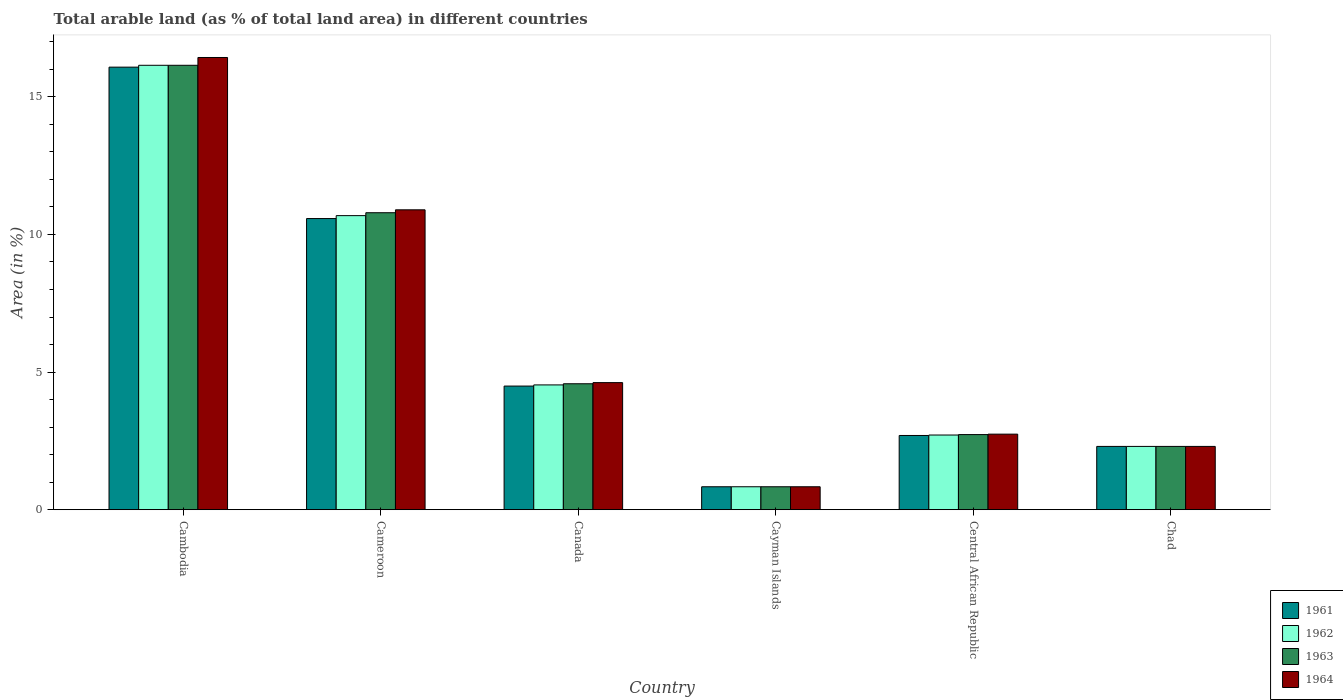How many different coloured bars are there?
Offer a terse response. 4. Are the number of bars per tick equal to the number of legend labels?
Ensure brevity in your answer.  Yes. How many bars are there on the 1st tick from the left?
Offer a very short reply. 4. What is the percentage of arable land in 1964 in Central African Republic?
Keep it short and to the point. 2.74. Across all countries, what is the maximum percentage of arable land in 1961?
Offer a terse response. 16.08. Across all countries, what is the minimum percentage of arable land in 1961?
Give a very brief answer. 0.83. In which country was the percentage of arable land in 1962 maximum?
Give a very brief answer. Cambodia. In which country was the percentage of arable land in 1961 minimum?
Your answer should be compact. Cayman Islands. What is the total percentage of arable land in 1962 in the graph?
Make the answer very short. 37.21. What is the difference between the percentage of arable land in 1963 in Cambodia and that in Central African Republic?
Make the answer very short. 13.42. What is the difference between the percentage of arable land in 1962 in Central African Republic and the percentage of arable land in 1964 in Chad?
Make the answer very short. 0.41. What is the average percentage of arable land in 1961 per country?
Keep it short and to the point. 6.16. What is the difference between the percentage of arable land of/in 1964 and percentage of arable land of/in 1962 in Chad?
Your answer should be compact. 0. What is the ratio of the percentage of arable land in 1961 in Cameroon to that in Chad?
Your answer should be very brief. 4.6. Is the difference between the percentage of arable land in 1964 in Cameroon and Cayman Islands greater than the difference between the percentage of arable land in 1962 in Cameroon and Cayman Islands?
Your answer should be compact. Yes. What is the difference between the highest and the second highest percentage of arable land in 1964?
Offer a very short reply. 5.53. What is the difference between the highest and the lowest percentage of arable land in 1962?
Your answer should be compact. 15.31. In how many countries, is the percentage of arable land in 1964 greater than the average percentage of arable land in 1964 taken over all countries?
Your answer should be compact. 2. Is the sum of the percentage of arable land in 1962 in Cayman Islands and Chad greater than the maximum percentage of arable land in 1963 across all countries?
Keep it short and to the point. No. Is it the case that in every country, the sum of the percentage of arable land in 1961 and percentage of arable land in 1962 is greater than the sum of percentage of arable land in 1964 and percentage of arable land in 1963?
Keep it short and to the point. No. What does the 4th bar from the left in Central African Republic represents?
Provide a short and direct response. 1964. What does the 4th bar from the right in Chad represents?
Your answer should be very brief. 1961. Are all the bars in the graph horizontal?
Ensure brevity in your answer.  No. Does the graph contain grids?
Provide a succinct answer. No. How many legend labels are there?
Keep it short and to the point. 4. How are the legend labels stacked?
Provide a succinct answer. Vertical. What is the title of the graph?
Keep it short and to the point. Total arable land (as % of total land area) in different countries. What is the label or title of the Y-axis?
Provide a succinct answer. Area (in %). What is the Area (in %) of 1961 in Cambodia?
Ensure brevity in your answer.  16.08. What is the Area (in %) of 1962 in Cambodia?
Give a very brief answer. 16.15. What is the Area (in %) in 1963 in Cambodia?
Offer a very short reply. 16.15. What is the Area (in %) in 1964 in Cambodia?
Your answer should be compact. 16.43. What is the Area (in %) of 1961 in Cameroon?
Give a very brief answer. 10.58. What is the Area (in %) of 1962 in Cameroon?
Make the answer very short. 10.68. What is the Area (in %) in 1963 in Cameroon?
Provide a short and direct response. 10.79. What is the Area (in %) of 1964 in Cameroon?
Make the answer very short. 10.89. What is the Area (in %) of 1961 in Canada?
Ensure brevity in your answer.  4.49. What is the Area (in %) of 1962 in Canada?
Give a very brief answer. 4.53. What is the Area (in %) of 1963 in Canada?
Your response must be concise. 4.58. What is the Area (in %) in 1964 in Canada?
Your answer should be very brief. 4.62. What is the Area (in %) in 1961 in Cayman Islands?
Offer a terse response. 0.83. What is the Area (in %) of 1962 in Cayman Islands?
Keep it short and to the point. 0.83. What is the Area (in %) of 1963 in Cayman Islands?
Give a very brief answer. 0.83. What is the Area (in %) of 1964 in Cayman Islands?
Your answer should be compact. 0.83. What is the Area (in %) in 1961 in Central African Republic?
Provide a succinct answer. 2.7. What is the Area (in %) of 1962 in Central African Republic?
Make the answer very short. 2.71. What is the Area (in %) of 1963 in Central African Republic?
Keep it short and to the point. 2.73. What is the Area (in %) in 1964 in Central African Republic?
Ensure brevity in your answer.  2.74. What is the Area (in %) in 1961 in Chad?
Make the answer very short. 2.3. What is the Area (in %) of 1962 in Chad?
Provide a succinct answer. 2.3. What is the Area (in %) in 1963 in Chad?
Keep it short and to the point. 2.3. What is the Area (in %) in 1964 in Chad?
Offer a very short reply. 2.3. Across all countries, what is the maximum Area (in %) in 1961?
Make the answer very short. 16.08. Across all countries, what is the maximum Area (in %) in 1962?
Give a very brief answer. 16.15. Across all countries, what is the maximum Area (in %) of 1963?
Make the answer very short. 16.15. Across all countries, what is the maximum Area (in %) in 1964?
Offer a terse response. 16.43. Across all countries, what is the minimum Area (in %) in 1961?
Provide a short and direct response. 0.83. Across all countries, what is the minimum Area (in %) in 1962?
Keep it short and to the point. 0.83. Across all countries, what is the minimum Area (in %) in 1963?
Give a very brief answer. 0.83. Across all countries, what is the minimum Area (in %) of 1964?
Offer a terse response. 0.83. What is the total Area (in %) in 1961 in the graph?
Provide a short and direct response. 36.98. What is the total Area (in %) of 1962 in the graph?
Offer a very short reply. 37.21. What is the total Area (in %) in 1963 in the graph?
Your response must be concise. 37.37. What is the total Area (in %) of 1964 in the graph?
Offer a terse response. 37.82. What is the difference between the Area (in %) of 1961 in Cambodia and that in Cameroon?
Your answer should be compact. 5.5. What is the difference between the Area (in %) in 1962 in Cambodia and that in Cameroon?
Ensure brevity in your answer.  5.46. What is the difference between the Area (in %) of 1963 in Cambodia and that in Cameroon?
Offer a very short reply. 5.36. What is the difference between the Area (in %) in 1964 in Cambodia and that in Cameroon?
Your answer should be compact. 5.53. What is the difference between the Area (in %) in 1961 in Cambodia and that in Canada?
Offer a terse response. 11.59. What is the difference between the Area (in %) in 1962 in Cambodia and that in Canada?
Your response must be concise. 11.61. What is the difference between the Area (in %) of 1963 in Cambodia and that in Canada?
Make the answer very short. 11.57. What is the difference between the Area (in %) in 1964 in Cambodia and that in Canada?
Provide a short and direct response. 11.81. What is the difference between the Area (in %) in 1961 in Cambodia and that in Cayman Islands?
Your response must be concise. 15.24. What is the difference between the Area (in %) in 1962 in Cambodia and that in Cayman Islands?
Provide a succinct answer. 15.31. What is the difference between the Area (in %) in 1963 in Cambodia and that in Cayman Islands?
Provide a short and direct response. 15.31. What is the difference between the Area (in %) of 1964 in Cambodia and that in Cayman Islands?
Keep it short and to the point. 15.6. What is the difference between the Area (in %) of 1961 in Cambodia and that in Central African Republic?
Provide a succinct answer. 13.38. What is the difference between the Area (in %) of 1962 in Cambodia and that in Central African Republic?
Provide a short and direct response. 13.43. What is the difference between the Area (in %) in 1963 in Cambodia and that in Central African Republic?
Your answer should be very brief. 13.42. What is the difference between the Area (in %) in 1964 in Cambodia and that in Central African Republic?
Your answer should be very brief. 13.68. What is the difference between the Area (in %) of 1961 in Cambodia and that in Chad?
Keep it short and to the point. 13.78. What is the difference between the Area (in %) of 1962 in Cambodia and that in Chad?
Ensure brevity in your answer.  13.85. What is the difference between the Area (in %) in 1963 in Cambodia and that in Chad?
Your response must be concise. 13.85. What is the difference between the Area (in %) in 1964 in Cambodia and that in Chad?
Provide a short and direct response. 14.13. What is the difference between the Area (in %) of 1961 in Cameroon and that in Canada?
Make the answer very short. 6.09. What is the difference between the Area (in %) of 1962 in Cameroon and that in Canada?
Make the answer very short. 6.15. What is the difference between the Area (in %) of 1963 in Cameroon and that in Canada?
Offer a very short reply. 6.21. What is the difference between the Area (in %) of 1964 in Cameroon and that in Canada?
Make the answer very short. 6.28. What is the difference between the Area (in %) of 1961 in Cameroon and that in Cayman Islands?
Your answer should be compact. 9.74. What is the difference between the Area (in %) of 1962 in Cameroon and that in Cayman Islands?
Give a very brief answer. 9.85. What is the difference between the Area (in %) in 1963 in Cameroon and that in Cayman Islands?
Your answer should be very brief. 9.96. What is the difference between the Area (in %) of 1964 in Cameroon and that in Cayman Islands?
Your answer should be very brief. 10.06. What is the difference between the Area (in %) of 1961 in Cameroon and that in Central African Republic?
Keep it short and to the point. 7.88. What is the difference between the Area (in %) of 1962 in Cameroon and that in Central African Republic?
Your response must be concise. 7.97. What is the difference between the Area (in %) in 1963 in Cameroon and that in Central African Republic?
Keep it short and to the point. 8.06. What is the difference between the Area (in %) in 1964 in Cameroon and that in Central African Republic?
Ensure brevity in your answer.  8.15. What is the difference between the Area (in %) of 1961 in Cameroon and that in Chad?
Your answer should be compact. 8.28. What is the difference between the Area (in %) in 1962 in Cameroon and that in Chad?
Your answer should be compact. 8.38. What is the difference between the Area (in %) of 1963 in Cameroon and that in Chad?
Give a very brief answer. 8.49. What is the difference between the Area (in %) in 1964 in Cameroon and that in Chad?
Your answer should be compact. 8.6. What is the difference between the Area (in %) of 1961 in Canada and that in Cayman Islands?
Offer a very short reply. 3.66. What is the difference between the Area (in %) in 1962 in Canada and that in Cayman Islands?
Make the answer very short. 3.7. What is the difference between the Area (in %) in 1963 in Canada and that in Cayman Islands?
Provide a short and direct response. 3.74. What is the difference between the Area (in %) of 1964 in Canada and that in Cayman Islands?
Your answer should be compact. 3.78. What is the difference between the Area (in %) in 1961 in Canada and that in Central African Republic?
Provide a succinct answer. 1.79. What is the difference between the Area (in %) in 1962 in Canada and that in Central African Republic?
Offer a very short reply. 1.82. What is the difference between the Area (in %) of 1963 in Canada and that in Central African Republic?
Your answer should be compact. 1.85. What is the difference between the Area (in %) of 1964 in Canada and that in Central African Republic?
Provide a succinct answer. 1.87. What is the difference between the Area (in %) in 1961 in Canada and that in Chad?
Provide a succinct answer. 2.19. What is the difference between the Area (in %) in 1962 in Canada and that in Chad?
Make the answer very short. 2.23. What is the difference between the Area (in %) in 1963 in Canada and that in Chad?
Offer a very short reply. 2.28. What is the difference between the Area (in %) of 1964 in Canada and that in Chad?
Your answer should be very brief. 2.32. What is the difference between the Area (in %) in 1961 in Cayman Islands and that in Central African Republic?
Your response must be concise. -1.86. What is the difference between the Area (in %) in 1962 in Cayman Islands and that in Central African Republic?
Provide a succinct answer. -1.88. What is the difference between the Area (in %) in 1963 in Cayman Islands and that in Central African Republic?
Offer a terse response. -1.9. What is the difference between the Area (in %) in 1964 in Cayman Islands and that in Central African Republic?
Keep it short and to the point. -1.91. What is the difference between the Area (in %) in 1961 in Cayman Islands and that in Chad?
Offer a terse response. -1.47. What is the difference between the Area (in %) in 1962 in Cayman Islands and that in Chad?
Ensure brevity in your answer.  -1.47. What is the difference between the Area (in %) of 1963 in Cayman Islands and that in Chad?
Your answer should be very brief. -1.47. What is the difference between the Area (in %) of 1964 in Cayman Islands and that in Chad?
Make the answer very short. -1.47. What is the difference between the Area (in %) in 1961 in Central African Republic and that in Chad?
Make the answer very short. 0.4. What is the difference between the Area (in %) of 1962 in Central African Republic and that in Chad?
Provide a succinct answer. 0.41. What is the difference between the Area (in %) of 1963 in Central African Republic and that in Chad?
Offer a very short reply. 0.43. What is the difference between the Area (in %) in 1964 in Central African Republic and that in Chad?
Offer a terse response. 0.45. What is the difference between the Area (in %) in 1961 in Cambodia and the Area (in %) in 1962 in Cameroon?
Your response must be concise. 5.39. What is the difference between the Area (in %) in 1961 in Cambodia and the Area (in %) in 1963 in Cameroon?
Offer a terse response. 5.29. What is the difference between the Area (in %) of 1961 in Cambodia and the Area (in %) of 1964 in Cameroon?
Give a very brief answer. 5.18. What is the difference between the Area (in %) in 1962 in Cambodia and the Area (in %) in 1963 in Cameroon?
Offer a very short reply. 5.36. What is the difference between the Area (in %) in 1962 in Cambodia and the Area (in %) in 1964 in Cameroon?
Provide a succinct answer. 5.25. What is the difference between the Area (in %) of 1963 in Cambodia and the Area (in %) of 1964 in Cameroon?
Your answer should be compact. 5.25. What is the difference between the Area (in %) in 1961 in Cambodia and the Area (in %) in 1962 in Canada?
Make the answer very short. 11.54. What is the difference between the Area (in %) in 1961 in Cambodia and the Area (in %) in 1963 in Canada?
Provide a short and direct response. 11.5. What is the difference between the Area (in %) of 1961 in Cambodia and the Area (in %) of 1964 in Canada?
Your answer should be very brief. 11.46. What is the difference between the Area (in %) of 1962 in Cambodia and the Area (in %) of 1963 in Canada?
Your answer should be compact. 11.57. What is the difference between the Area (in %) of 1962 in Cambodia and the Area (in %) of 1964 in Canada?
Make the answer very short. 11.53. What is the difference between the Area (in %) of 1963 in Cambodia and the Area (in %) of 1964 in Canada?
Make the answer very short. 11.53. What is the difference between the Area (in %) of 1961 in Cambodia and the Area (in %) of 1962 in Cayman Islands?
Provide a succinct answer. 15.24. What is the difference between the Area (in %) in 1961 in Cambodia and the Area (in %) in 1963 in Cayman Islands?
Make the answer very short. 15.24. What is the difference between the Area (in %) in 1961 in Cambodia and the Area (in %) in 1964 in Cayman Islands?
Provide a succinct answer. 15.24. What is the difference between the Area (in %) of 1962 in Cambodia and the Area (in %) of 1963 in Cayman Islands?
Give a very brief answer. 15.31. What is the difference between the Area (in %) in 1962 in Cambodia and the Area (in %) in 1964 in Cayman Islands?
Your answer should be very brief. 15.31. What is the difference between the Area (in %) in 1963 in Cambodia and the Area (in %) in 1964 in Cayman Islands?
Offer a terse response. 15.31. What is the difference between the Area (in %) in 1961 in Cambodia and the Area (in %) in 1962 in Central African Republic?
Ensure brevity in your answer.  13.36. What is the difference between the Area (in %) in 1961 in Cambodia and the Area (in %) in 1963 in Central African Republic?
Ensure brevity in your answer.  13.35. What is the difference between the Area (in %) in 1961 in Cambodia and the Area (in %) in 1964 in Central African Republic?
Make the answer very short. 13.33. What is the difference between the Area (in %) in 1962 in Cambodia and the Area (in %) in 1963 in Central African Republic?
Your answer should be compact. 13.42. What is the difference between the Area (in %) in 1962 in Cambodia and the Area (in %) in 1964 in Central African Republic?
Provide a succinct answer. 13.4. What is the difference between the Area (in %) of 1963 in Cambodia and the Area (in %) of 1964 in Central African Republic?
Your answer should be compact. 13.4. What is the difference between the Area (in %) of 1961 in Cambodia and the Area (in %) of 1962 in Chad?
Offer a very short reply. 13.78. What is the difference between the Area (in %) of 1961 in Cambodia and the Area (in %) of 1963 in Chad?
Offer a very short reply. 13.78. What is the difference between the Area (in %) in 1961 in Cambodia and the Area (in %) in 1964 in Chad?
Provide a short and direct response. 13.78. What is the difference between the Area (in %) in 1962 in Cambodia and the Area (in %) in 1963 in Chad?
Make the answer very short. 13.85. What is the difference between the Area (in %) of 1962 in Cambodia and the Area (in %) of 1964 in Chad?
Give a very brief answer. 13.85. What is the difference between the Area (in %) of 1963 in Cambodia and the Area (in %) of 1964 in Chad?
Your answer should be compact. 13.85. What is the difference between the Area (in %) of 1961 in Cameroon and the Area (in %) of 1962 in Canada?
Make the answer very short. 6.04. What is the difference between the Area (in %) in 1961 in Cameroon and the Area (in %) in 1963 in Canada?
Offer a terse response. 6. What is the difference between the Area (in %) of 1961 in Cameroon and the Area (in %) of 1964 in Canada?
Keep it short and to the point. 5.96. What is the difference between the Area (in %) of 1962 in Cameroon and the Area (in %) of 1963 in Canada?
Provide a short and direct response. 6.11. What is the difference between the Area (in %) in 1962 in Cameroon and the Area (in %) in 1964 in Canada?
Provide a short and direct response. 6.07. What is the difference between the Area (in %) in 1963 in Cameroon and the Area (in %) in 1964 in Canada?
Your answer should be very brief. 6.17. What is the difference between the Area (in %) in 1961 in Cameroon and the Area (in %) in 1962 in Cayman Islands?
Give a very brief answer. 9.74. What is the difference between the Area (in %) in 1961 in Cameroon and the Area (in %) in 1963 in Cayman Islands?
Your answer should be compact. 9.74. What is the difference between the Area (in %) of 1961 in Cameroon and the Area (in %) of 1964 in Cayman Islands?
Keep it short and to the point. 9.74. What is the difference between the Area (in %) of 1962 in Cameroon and the Area (in %) of 1963 in Cayman Islands?
Ensure brevity in your answer.  9.85. What is the difference between the Area (in %) of 1962 in Cameroon and the Area (in %) of 1964 in Cayman Islands?
Your answer should be very brief. 9.85. What is the difference between the Area (in %) of 1963 in Cameroon and the Area (in %) of 1964 in Cayman Islands?
Your response must be concise. 9.96. What is the difference between the Area (in %) of 1961 in Cameroon and the Area (in %) of 1962 in Central African Republic?
Your answer should be compact. 7.86. What is the difference between the Area (in %) of 1961 in Cameroon and the Area (in %) of 1963 in Central African Republic?
Provide a succinct answer. 7.85. What is the difference between the Area (in %) in 1961 in Cameroon and the Area (in %) in 1964 in Central African Republic?
Offer a very short reply. 7.83. What is the difference between the Area (in %) in 1962 in Cameroon and the Area (in %) in 1963 in Central African Republic?
Give a very brief answer. 7.95. What is the difference between the Area (in %) of 1962 in Cameroon and the Area (in %) of 1964 in Central African Republic?
Your answer should be very brief. 7.94. What is the difference between the Area (in %) in 1963 in Cameroon and the Area (in %) in 1964 in Central African Republic?
Offer a terse response. 8.04. What is the difference between the Area (in %) in 1961 in Cameroon and the Area (in %) in 1962 in Chad?
Make the answer very short. 8.28. What is the difference between the Area (in %) of 1961 in Cameroon and the Area (in %) of 1963 in Chad?
Keep it short and to the point. 8.28. What is the difference between the Area (in %) of 1961 in Cameroon and the Area (in %) of 1964 in Chad?
Your answer should be very brief. 8.28. What is the difference between the Area (in %) of 1962 in Cameroon and the Area (in %) of 1963 in Chad?
Give a very brief answer. 8.38. What is the difference between the Area (in %) in 1962 in Cameroon and the Area (in %) in 1964 in Chad?
Ensure brevity in your answer.  8.38. What is the difference between the Area (in %) of 1963 in Cameroon and the Area (in %) of 1964 in Chad?
Your answer should be very brief. 8.49. What is the difference between the Area (in %) in 1961 in Canada and the Area (in %) in 1962 in Cayman Islands?
Offer a very short reply. 3.66. What is the difference between the Area (in %) of 1961 in Canada and the Area (in %) of 1963 in Cayman Islands?
Give a very brief answer. 3.66. What is the difference between the Area (in %) in 1961 in Canada and the Area (in %) in 1964 in Cayman Islands?
Your answer should be very brief. 3.66. What is the difference between the Area (in %) in 1962 in Canada and the Area (in %) in 1964 in Cayman Islands?
Make the answer very short. 3.7. What is the difference between the Area (in %) of 1963 in Canada and the Area (in %) of 1964 in Cayman Islands?
Provide a succinct answer. 3.74. What is the difference between the Area (in %) of 1961 in Canada and the Area (in %) of 1962 in Central African Republic?
Ensure brevity in your answer.  1.78. What is the difference between the Area (in %) in 1961 in Canada and the Area (in %) in 1963 in Central African Republic?
Provide a short and direct response. 1.76. What is the difference between the Area (in %) of 1961 in Canada and the Area (in %) of 1964 in Central African Republic?
Give a very brief answer. 1.75. What is the difference between the Area (in %) in 1962 in Canada and the Area (in %) in 1963 in Central African Republic?
Provide a succinct answer. 1.8. What is the difference between the Area (in %) of 1962 in Canada and the Area (in %) of 1964 in Central African Republic?
Ensure brevity in your answer.  1.79. What is the difference between the Area (in %) in 1963 in Canada and the Area (in %) in 1964 in Central African Republic?
Offer a terse response. 1.83. What is the difference between the Area (in %) of 1961 in Canada and the Area (in %) of 1962 in Chad?
Your response must be concise. 2.19. What is the difference between the Area (in %) in 1961 in Canada and the Area (in %) in 1963 in Chad?
Your answer should be very brief. 2.19. What is the difference between the Area (in %) of 1961 in Canada and the Area (in %) of 1964 in Chad?
Your response must be concise. 2.19. What is the difference between the Area (in %) in 1962 in Canada and the Area (in %) in 1963 in Chad?
Make the answer very short. 2.23. What is the difference between the Area (in %) in 1962 in Canada and the Area (in %) in 1964 in Chad?
Provide a succinct answer. 2.23. What is the difference between the Area (in %) of 1963 in Canada and the Area (in %) of 1964 in Chad?
Give a very brief answer. 2.28. What is the difference between the Area (in %) of 1961 in Cayman Islands and the Area (in %) of 1962 in Central African Republic?
Your response must be concise. -1.88. What is the difference between the Area (in %) of 1961 in Cayman Islands and the Area (in %) of 1963 in Central African Republic?
Your answer should be compact. -1.9. What is the difference between the Area (in %) in 1961 in Cayman Islands and the Area (in %) in 1964 in Central African Republic?
Your response must be concise. -1.91. What is the difference between the Area (in %) of 1962 in Cayman Islands and the Area (in %) of 1963 in Central African Republic?
Your response must be concise. -1.9. What is the difference between the Area (in %) in 1962 in Cayman Islands and the Area (in %) in 1964 in Central African Republic?
Your answer should be very brief. -1.91. What is the difference between the Area (in %) of 1963 in Cayman Islands and the Area (in %) of 1964 in Central African Republic?
Your response must be concise. -1.91. What is the difference between the Area (in %) of 1961 in Cayman Islands and the Area (in %) of 1962 in Chad?
Provide a short and direct response. -1.47. What is the difference between the Area (in %) in 1961 in Cayman Islands and the Area (in %) in 1963 in Chad?
Your answer should be compact. -1.47. What is the difference between the Area (in %) of 1961 in Cayman Islands and the Area (in %) of 1964 in Chad?
Your response must be concise. -1.47. What is the difference between the Area (in %) of 1962 in Cayman Islands and the Area (in %) of 1963 in Chad?
Your answer should be very brief. -1.47. What is the difference between the Area (in %) of 1962 in Cayman Islands and the Area (in %) of 1964 in Chad?
Ensure brevity in your answer.  -1.47. What is the difference between the Area (in %) in 1963 in Cayman Islands and the Area (in %) in 1964 in Chad?
Provide a short and direct response. -1.47. What is the difference between the Area (in %) in 1961 in Central African Republic and the Area (in %) in 1962 in Chad?
Offer a very short reply. 0.4. What is the difference between the Area (in %) of 1961 in Central African Republic and the Area (in %) of 1963 in Chad?
Ensure brevity in your answer.  0.4. What is the difference between the Area (in %) of 1961 in Central African Republic and the Area (in %) of 1964 in Chad?
Provide a short and direct response. 0.4. What is the difference between the Area (in %) of 1962 in Central African Republic and the Area (in %) of 1963 in Chad?
Your answer should be compact. 0.41. What is the difference between the Area (in %) in 1962 in Central African Republic and the Area (in %) in 1964 in Chad?
Your answer should be compact. 0.41. What is the difference between the Area (in %) in 1963 in Central African Republic and the Area (in %) in 1964 in Chad?
Provide a succinct answer. 0.43. What is the average Area (in %) in 1961 per country?
Your answer should be compact. 6.16. What is the average Area (in %) of 1962 per country?
Your response must be concise. 6.2. What is the average Area (in %) in 1963 per country?
Keep it short and to the point. 6.23. What is the average Area (in %) in 1964 per country?
Provide a short and direct response. 6.3. What is the difference between the Area (in %) in 1961 and Area (in %) in 1962 in Cambodia?
Your response must be concise. -0.07. What is the difference between the Area (in %) in 1961 and Area (in %) in 1963 in Cambodia?
Keep it short and to the point. -0.07. What is the difference between the Area (in %) in 1961 and Area (in %) in 1964 in Cambodia?
Keep it short and to the point. -0.35. What is the difference between the Area (in %) of 1962 and Area (in %) of 1963 in Cambodia?
Your answer should be very brief. 0. What is the difference between the Area (in %) of 1962 and Area (in %) of 1964 in Cambodia?
Your answer should be compact. -0.28. What is the difference between the Area (in %) in 1963 and Area (in %) in 1964 in Cambodia?
Ensure brevity in your answer.  -0.28. What is the difference between the Area (in %) in 1961 and Area (in %) in 1962 in Cameroon?
Ensure brevity in your answer.  -0.11. What is the difference between the Area (in %) in 1961 and Area (in %) in 1963 in Cameroon?
Your response must be concise. -0.21. What is the difference between the Area (in %) of 1961 and Area (in %) of 1964 in Cameroon?
Provide a short and direct response. -0.32. What is the difference between the Area (in %) of 1962 and Area (in %) of 1963 in Cameroon?
Make the answer very short. -0.11. What is the difference between the Area (in %) of 1962 and Area (in %) of 1964 in Cameroon?
Keep it short and to the point. -0.21. What is the difference between the Area (in %) in 1963 and Area (in %) in 1964 in Cameroon?
Make the answer very short. -0.11. What is the difference between the Area (in %) of 1961 and Area (in %) of 1962 in Canada?
Offer a very short reply. -0.04. What is the difference between the Area (in %) of 1961 and Area (in %) of 1963 in Canada?
Your answer should be very brief. -0.08. What is the difference between the Area (in %) in 1961 and Area (in %) in 1964 in Canada?
Provide a succinct answer. -0.13. What is the difference between the Area (in %) in 1962 and Area (in %) in 1963 in Canada?
Your answer should be compact. -0.04. What is the difference between the Area (in %) of 1962 and Area (in %) of 1964 in Canada?
Make the answer very short. -0.08. What is the difference between the Area (in %) of 1963 and Area (in %) of 1964 in Canada?
Offer a very short reply. -0.04. What is the difference between the Area (in %) in 1961 and Area (in %) in 1963 in Cayman Islands?
Keep it short and to the point. 0. What is the difference between the Area (in %) of 1962 and Area (in %) of 1963 in Cayman Islands?
Offer a terse response. 0. What is the difference between the Area (in %) in 1961 and Area (in %) in 1962 in Central African Republic?
Keep it short and to the point. -0.02. What is the difference between the Area (in %) of 1961 and Area (in %) of 1963 in Central African Republic?
Make the answer very short. -0.03. What is the difference between the Area (in %) of 1961 and Area (in %) of 1964 in Central African Republic?
Your answer should be compact. -0.05. What is the difference between the Area (in %) in 1962 and Area (in %) in 1963 in Central African Republic?
Keep it short and to the point. -0.02. What is the difference between the Area (in %) of 1962 and Area (in %) of 1964 in Central African Republic?
Provide a short and direct response. -0.03. What is the difference between the Area (in %) in 1963 and Area (in %) in 1964 in Central African Republic?
Keep it short and to the point. -0.02. What is the difference between the Area (in %) in 1961 and Area (in %) in 1964 in Chad?
Your response must be concise. 0. What is the difference between the Area (in %) in 1963 and Area (in %) in 1964 in Chad?
Ensure brevity in your answer.  0. What is the ratio of the Area (in %) of 1961 in Cambodia to that in Cameroon?
Your answer should be very brief. 1.52. What is the ratio of the Area (in %) of 1962 in Cambodia to that in Cameroon?
Keep it short and to the point. 1.51. What is the ratio of the Area (in %) of 1963 in Cambodia to that in Cameroon?
Offer a terse response. 1.5. What is the ratio of the Area (in %) of 1964 in Cambodia to that in Cameroon?
Provide a succinct answer. 1.51. What is the ratio of the Area (in %) in 1961 in Cambodia to that in Canada?
Your answer should be very brief. 3.58. What is the ratio of the Area (in %) in 1962 in Cambodia to that in Canada?
Ensure brevity in your answer.  3.56. What is the ratio of the Area (in %) of 1963 in Cambodia to that in Canada?
Your response must be concise. 3.53. What is the ratio of the Area (in %) in 1964 in Cambodia to that in Canada?
Your answer should be very brief. 3.56. What is the ratio of the Area (in %) of 1961 in Cambodia to that in Cayman Islands?
Provide a short and direct response. 19.29. What is the ratio of the Area (in %) in 1962 in Cambodia to that in Cayman Islands?
Offer a terse response. 19.37. What is the ratio of the Area (in %) of 1963 in Cambodia to that in Cayman Islands?
Ensure brevity in your answer.  19.37. What is the ratio of the Area (in %) in 1964 in Cambodia to that in Cayman Islands?
Offer a very short reply. 19.71. What is the ratio of the Area (in %) in 1961 in Cambodia to that in Central African Republic?
Offer a very short reply. 5.96. What is the ratio of the Area (in %) in 1962 in Cambodia to that in Central African Republic?
Make the answer very short. 5.95. What is the ratio of the Area (in %) in 1963 in Cambodia to that in Central African Republic?
Your answer should be very brief. 5.92. What is the ratio of the Area (in %) of 1964 in Cambodia to that in Central African Republic?
Provide a succinct answer. 5.99. What is the ratio of the Area (in %) in 1961 in Cambodia to that in Chad?
Your response must be concise. 6.99. What is the ratio of the Area (in %) in 1962 in Cambodia to that in Chad?
Offer a terse response. 7.02. What is the ratio of the Area (in %) in 1963 in Cambodia to that in Chad?
Provide a short and direct response. 7.02. What is the ratio of the Area (in %) in 1964 in Cambodia to that in Chad?
Offer a very short reply. 7.15. What is the ratio of the Area (in %) in 1961 in Cameroon to that in Canada?
Offer a very short reply. 2.35. What is the ratio of the Area (in %) in 1962 in Cameroon to that in Canada?
Your response must be concise. 2.36. What is the ratio of the Area (in %) of 1963 in Cameroon to that in Canada?
Give a very brief answer. 2.36. What is the ratio of the Area (in %) of 1964 in Cameroon to that in Canada?
Offer a very short reply. 2.36. What is the ratio of the Area (in %) in 1961 in Cameroon to that in Cayman Islands?
Your answer should be very brief. 12.69. What is the ratio of the Area (in %) in 1962 in Cameroon to that in Cayman Islands?
Offer a terse response. 12.82. What is the ratio of the Area (in %) of 1963 in Cameroon to that in Cayman Islands?
Give a very brief answer. 12.95. What is the ratio of the Area (in %) of 1964 in Cameroon to that in Cayman Islands?
Ensure brevity in your answer.  13.07. What is the ratio of the Area (in %) of 1961 in Cameroon to that in Central African Republic?
Your answer should be compact. 3.92. What is the ratio of the Area (in %) of 1962 in Cameroon to that in Central African Republic?
Make the answer very short. 3.94. What is the ratio of the Area (in %) in 1963 in Cameroon to that in Central African Republic?
Ensure brevity in your answer.  3.95. What is the ratio of the Area (in %) in 1964 in Cameroon to that in Central African Republic?
Keep it short and to the point. 3.97. What is the ratio of the Area (in %) of 1961 in Cameroon to that in Chad?
Provide a short and direct response. 4.6. What is the ratio of the Area (in %) of 1962 in Cameroon to that in Chad?
Offer a very short reply. 4.65. What is the ratio of the Area (in %) in 1963 in Cameroon to that in Chad?
Ensure brevity in your answer.  4.69. What is the ratio of the Area (in %) in 1964 in Cameroon to that in Chad?
Your answer should be compact. 4.74. What is the ratio of the Area (in %) of 1961 in Canada to that in Cayman Islands?
Keep it short and to the point. 5.39. What is the ratio of the Area (in %) in 1962 in Canada to that in Cayman Islands?
Give a very brief answer. 5.44. What is the ratio of the Area (in %) in 1963 in Canada to that in Cayman Islands?
Your answer should be very brief. 5.49. What is the ratio of the Area (in %) of 1964 in Canada to that in Cayman Islands?
Ensure brevity in your answer.  5.54. What is the ratio of the Area (in %) in 1961 in Canada to that in Central African Republic?
Your answer should be compact. 1.67. What is the ratio of the Area (in %) of 1962 in Canada to that in Central African Republic?
Keep it short and to the point. 1.67. What is the ratio of the Area (in %) of 1963 in Canada to that in Central African Republic?
Make the answer very short. 1.68. What is the ratio of the Area (in %) in 1964 in Canada to that in Central African Republic?
Your answer should be compact. 1.68. What is the ratio of the Area (in %) in 1961 in Canada to that in Chad?
Ensure brevity in your answer.  1.95. What is the ratio of the Area (in %) in 1962 in Canada to that in Chad?
Your answer should be compact. 1.97. What is the ratio of the Area (in %) of 1963 in Canada to that in Chad?
Provide a succinct answer. 1.99. What is the ratio of the Area (in %) in 1964 in Canada to that in Chad?
Make the answer very short. 2.01. What is the ratio of the Area (in %) in 1961 in Cayman Islands to that in Central African Republic?
Give a very brief answer. 0.31. What is the ratio of the Area (in %) in 1962 in Cayman Islands to that in Central African Republic?
Your answer should be very brief. 0.31. What is the ratio of the Area (in %) in 1963 in Cayman Islands to that in Central African Republic?
Give a very brief answer. 0.31. What is the ratio of the Area (in %) of 1964 in Cayman Islands to that in Central African Republic?
Provide a short and direct response. 0.3. What is the ratio of the Area (in %) of 1961 in Cayman Islands to that in Chad?
Provide a short and direct response. 0.36. What is the ratio of the Area (in %) in 1962 in Cayman Islands to that in Chad?
Your response must be concise. 0.36. What is the ratio of the Area (in %) of 1963 in Cayman Islands to that in Chad?
Keep it short and to the point. 0.36. What is the ratio of the Area (in %) in 1964 in Cayman Islands to that in Chad?
Keep it short and to the point. 0.36. What is the ratio of the Area (in %) of 1961 in Central African Republic to that in Chad?
Provide a succinct answer. 1.17. What is the ratio of the Area (in %) of 1962 in Central African Republic to that in Chad?
Your response must be concise. 1.18. What is the ratio of the Area (in %) in 1963 in Central African Republic to that in Chad?
Ensure brevity in your answer.  1.19. What is the ratio of the Area (in %) of 1964 in Central African Republic to that in Chad?
Offer a very short reply. 1.19. What is the difference between the highest and the second highest Area (in %) of 1961?
Give a very brief answer. 5.5. What is the difference between the highest and the second highest Area (in %) of 1962?
Give a very brief answer. 5.46. What is the difference between the highest and the second highest Area (in %) in 1963?
Make the answer very short. 5.36. What is the difference between the highest and the second highest Area (in %) of 1964?
Provide a short and direct response. 5.53. What is the difference between the highest and the lowest Area (in %) of 1961?
Offer a very short reply. 15.24. What is the difference between the highest and the lowest Area (in %) of 1962?
Make the answer very short. 15.31. What is the difference between the highest and the lowest Area (in %) of 1963?
Your response must be concise. 15.31. What is the difference between the highest and the lowest Area (in %) of 1964?
Offer a terse response. 15.6. 